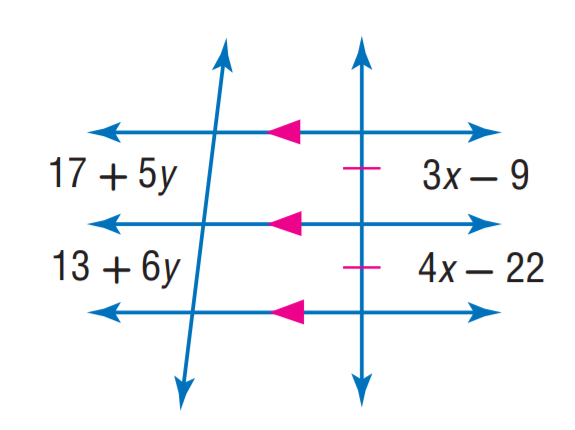Question: Find y.
Choices:
A. 3
B. 4
C. 6
D. 9
Answer with the letter. Answer: B Question: Find x.
Choices:
A. 9
B. 13
C. 16
D. 22
Answer with the letter. Answer: B 